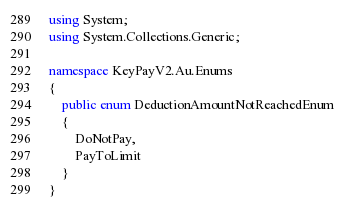<code> <loc_0><loc_0><loc_500><loc_500><_C#_>using System;
using System.Collections.Generic;

namespace KeyPayV2.Au.Enums
{
    public enum DeductionAmountNotReachedEnum
    {
        DoNotPay,
        PayToLimit
    }
}
</code> 